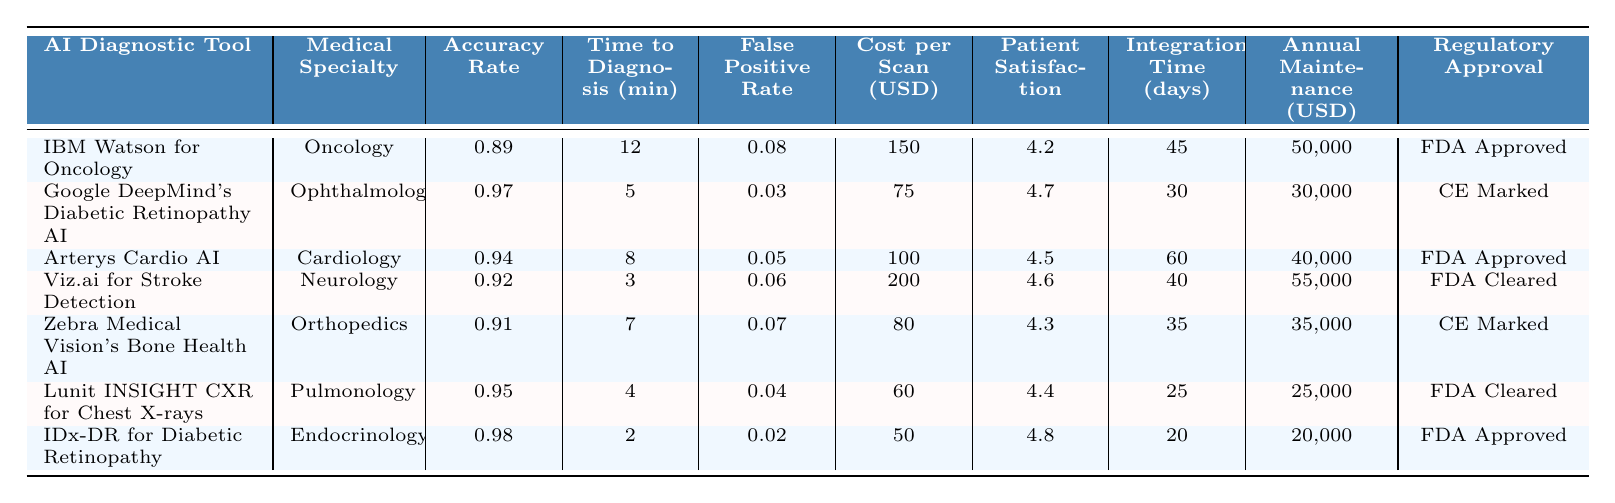What is the accuracy rate of Google DeepMind's Diabetic Retinopathy AI? By looking at the row for Google DeepMind's Diabetic Retinopathy AI, the accuracy rate is reported next to it.
Answer: 0.97 Which AI diagnostic tool has the lowest cost per scan? The costs per scan for the tools are listed in a column, with IDx-DR for Diabetic Retinopathy showing the lowest cost at $50.
Answer: $50 How much time does it take for Viz.ai for Stroke Detection to provide a diagnosis? The time to diagnosis for Viz.ai for Stroke Detection is stated in the corresponding row which shows 3 minutes.
Answer: 3 minutes Which medical specialty has the highest patient satisfaction score? The patient satisfaction scores are provided in a column, with IDx-DR for Diabetic Retinopathy scoring the highest at 4.8.
Answer: 4.8 What is the average accuracy rate of the AI diagnostic tools listed? The accuracy rates are 0.89, 0.97, 0.94, 0.92, 0.91, 0.95, and 0.98. Adding these together gives 6.56. Dividing by 7 gives an average of approximately 0.94.
Answer: 0.94 Is the regulatory approval status for Zebra Medical Vision's Bone Health AI "FDA Cleared"? Looking at the regulatory approval column for Zebra Medical Vision's Bone Health AI, it shows "CE Marked" instead.
Answer: No Which AI diagnostic tool requires the longest integration time? Checking the integration times, Arterys Cardio AI shows the longest duration of 60 days.
Answer: 60 days If we sum the annual maintenance costs of all the tools, what is the total? The annual maintenance costs are 50,000, 30,000, 40,000, 55,000, 35,000, 25,000, and 20,000, giving a total of 255,000 when summed.
Answer: $255,000 Which AI diagnostic tool has the highest false positive rate? The false positive rates are displayed in the table, and by comparing them, IBM Watson for Oncology has the highest rate of 0.08.
Answer: 0.08 What is the cost difference between the highest and lowest cost per scan? The highest cost per scan is $200 for Viz.ai for Stroke Detection, and the lowest is $50 for IDx-DR. The difference is 200 - 50 = 150.
Answer: $150 